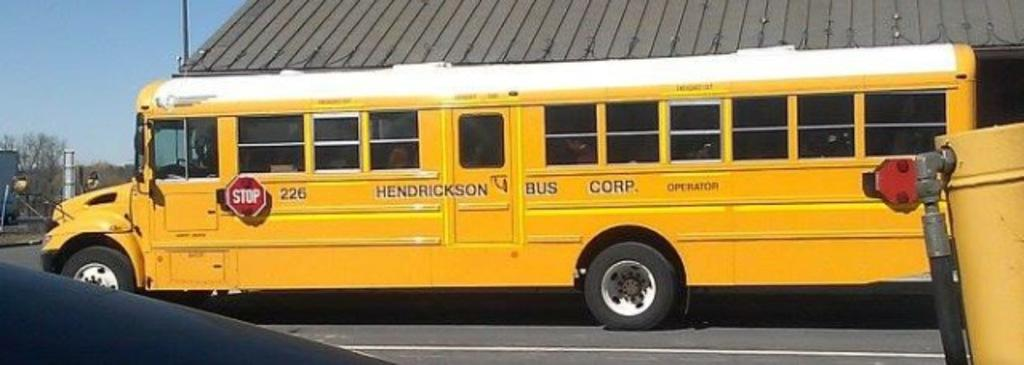<image>
Give a short and clear explanation of the subsequent image. Hendrickson Bus Corp. is displayed on the side of a yellow school bus 